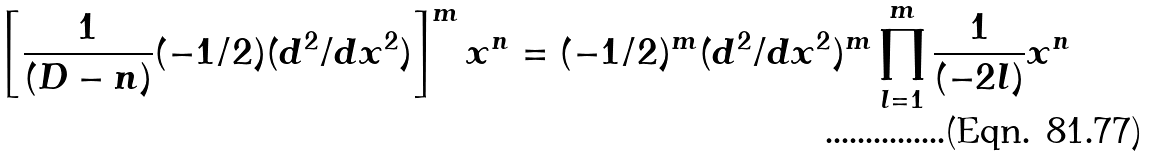Convert formula to latex. <formula><loc_0><loc_0><loc_500><loc_500>\left [ \frac { 1 } { ( D - n ) } ( - 1 / 2 ) ( d ^ { 2 } / d x ^ { 2 } ) \right ] ^ { m } x ^ { n } = ( - 1 / 2 ) ^ { m } ( d ^ { 2 } / d x ^ { 2 } ) ^ { m } \prod _ { l = 1 } ^ { m } \frac { 1 } { ( - 2 l ) } x ^ { n }</formula> 